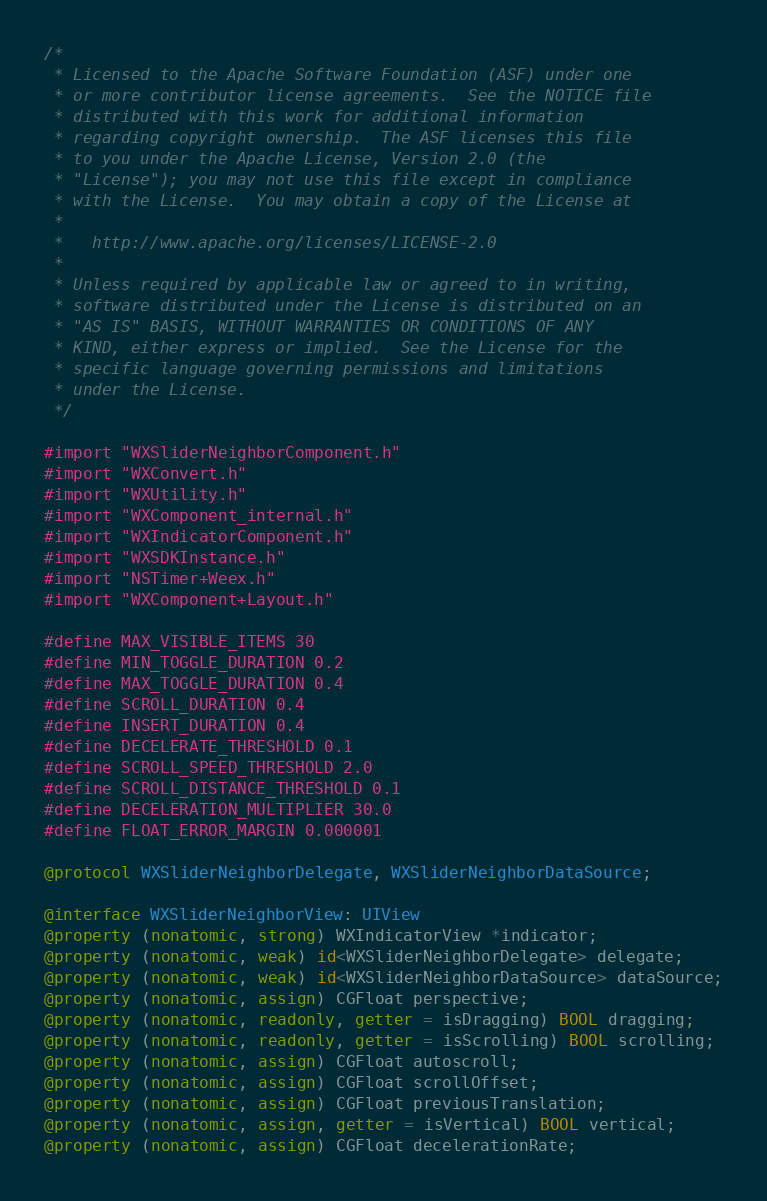<code> <loc_0><loc_0><loc_500><loc_500><_ObjectiveC_>/*
 * Licensed to the Apache Software Foundation (ASF) under one
 * or more contributor license agreements.  See the NOTICE file
 * distributed with this work for additional information
 * regarding copyright ownership.  The ASF licenses this file
 * to you under the Apache License, Version 2.0 (the
 * "License"); you may not use this file except in compliance
 * with the License.  You may obtain a copy of the License at
 *
 *   http://www.apache.org/licenses/LICENSE-2.0
 *
 * Unless required by applicable law or agreed to in writing,
 * software distributed under the License is distributed on an
 * "AS IS" BASIS, WITHOUT WARRANTIES OR CONDITIONS OF ANY
 * KIND, either express or implied.  See the License for the
 * specific language governing permissions and limitations
 * under the License.
 */

#import "WXSliderNeighborComponent.h"
#import "WXConvert.h"
#import "WXUtility.h"
#import "WXComponent_internal.h"
#import "WXIndicatorComponent.h"
#import "WXSDKInstance.h"
#import "NSTimer+Weex.h"
#import "WXComponent+Layout.h"

#define MAX_VISIBLE_ITEMS 30
#define MIN_TOGGLE_DURATION 0.2
#define MAX_TOGGLE_DURATION 0.4
#define SCROLL_DURATION 0.4
#define INSERT_DURATION 0.4
#define DECELERATE_THRESHOLD 0.1
#define SCROLL_SPEED_THRESHOLD 2.0
#define SCROLL_DISTANCE_THRESHOLD 0.1
#define DECELERATION_MULTIPLIER 30.0
#define FLOAT_ERROR_MARGIN 0.000001

@protocol WXSliderNeighborDelegate, WXSliderNeighborDataSource;

@interface WXSliderNeighborView: UIView
@property (nonatomic, strong) WXIndicatorView *indicator;
@property (nonatomic, weak) id<WXSliderNeighborDelegate> delegate;
@property (nonatomic, weak) id<WXSliderNeighborDataSource> dataSource;
@property (nonatomic, assign) CGFloat perspective;
@property (nonatomic, readonly, getter = isDragging) BOOL dragging;
@property (nonatomic, readonly, getter = isScrolling) BOOL scrolling;
@property (nonatomic, assign) CGFloat autoscroll;
@property (nonatomic, assign) CGFloat scrollOffset;
@property (nonatomic, assign) CGFloat previousTranslation;
@property (nonatomic, assign, getter = isVertical) BOOL vertical;
@property (nonatomic, assign) CGFloat decelerationRate;</code> 